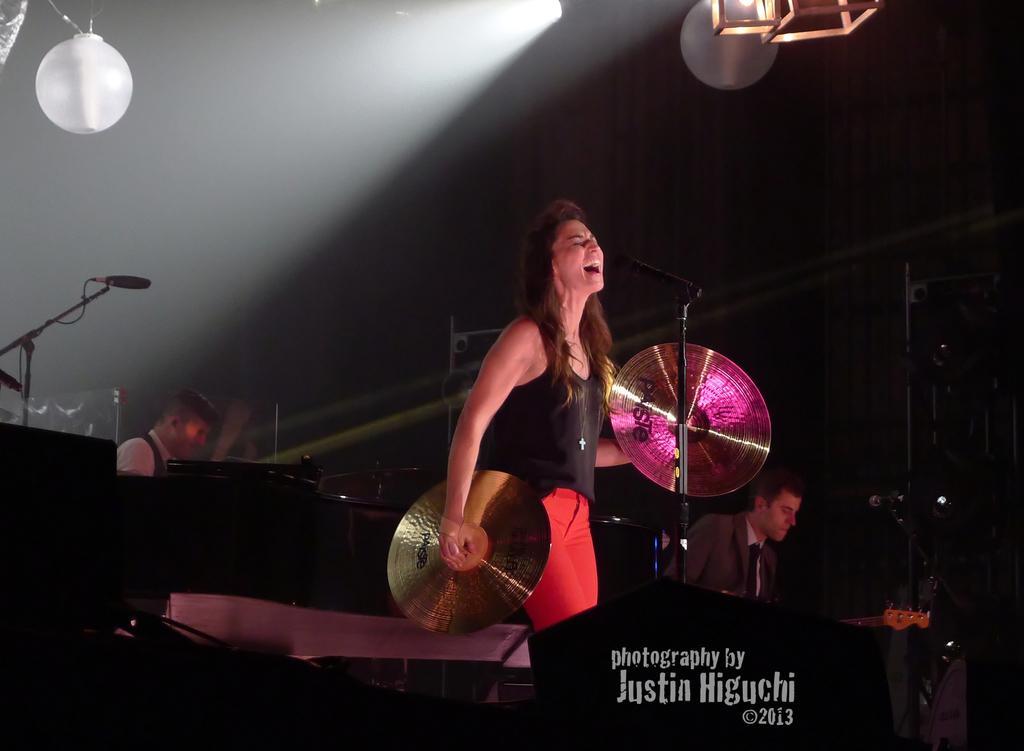Describe this image in one or two sentences. In this picture I can see couple of men and a woman playing musical instruments and I can see couple of microphones and text at the bottom of the picture. 